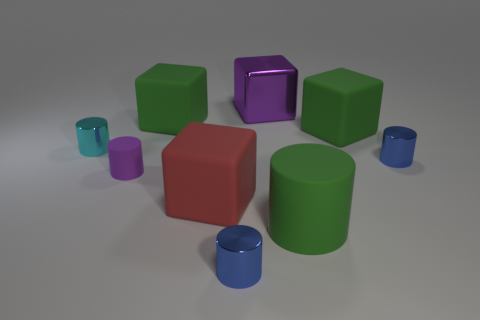Subtract all cyan cylinders. How many cylinders are left? 4 Subtract 1 blocks. How many blocks are left? 3 Subtract all tiny cyan metal cylinders. How many cylinders are left? 4 Subtract all blue blocks. Subtract all gray cylinders. How many blocks are left? 4 Subtract all cylinders. How many objects are left? 4 Subtract 0 green spheres. How many objects are left? 9 Subtract all big matte cylinders. Subtract all cyan metallic cylinders. How many objects are left? 7 Add 5 big purple objects. How many big purple objects are left? 6 Add 2 gray balls. How many gray balls exist? 2 